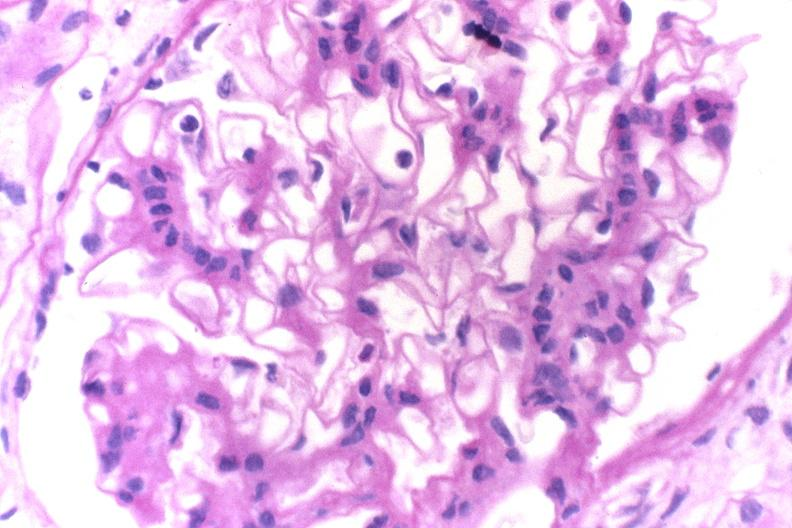s stein leventhal present?
Answer the question using a single word or phrase. No 